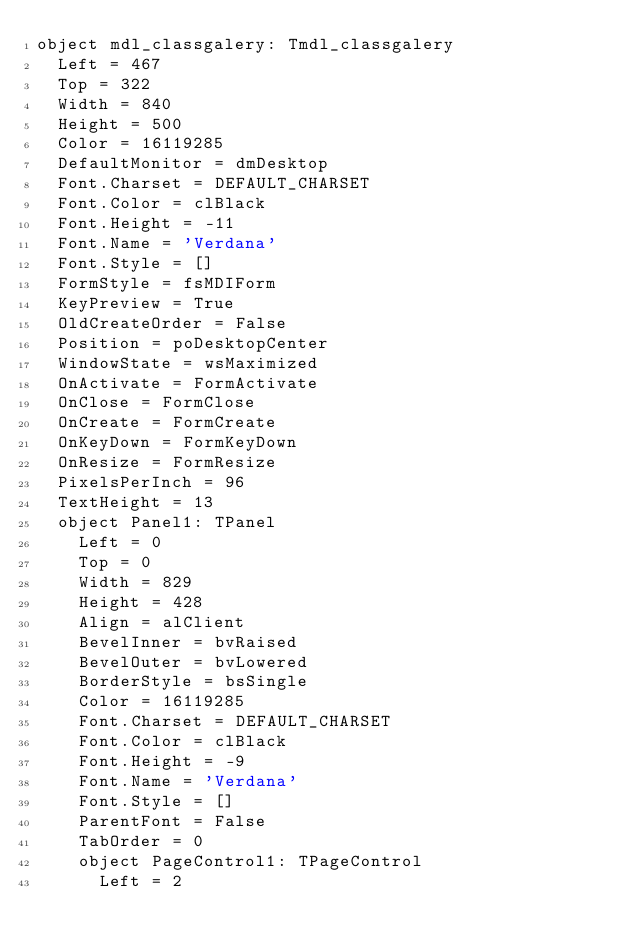<code> <loc_0><loc_0><loc_500><loc_500><_Pascal_>object mdl_classgalery: Tmdl_classgalery
  Left = 467
  Top = 322
  Width = 840
  Height = 500
  Color = 16119285
  DefaultMonitor = dmDesktop
  Font.Charset = DEFAULT_CHARSET
  Font.Color = clBlack
  Font.Height = -11
  Font.Name = 'Verdana'
  Font.Style = []
  FormStyle = fsMDIForm
  KeyPreview = True
  OldCreateOrder = False
  Position = poDesktopCenter
  WindowState = wsMaximized
  OnActivate = FormActivate
  OnClose = FormClose
  OnCreate = FormCreate
  OnKeyDown = FormKeyDown
  OnResize = FormResize
  PixelsPerInch = 96
  TextHeight = 13
  object Panel1: TPanel
    Left = 0
    Top = 0
    Width = 829
    Height = 428
    Align = alClient
    BevelInner = bvRaised
    BevelOuter = bvLowered
    BorderStyle = bsSingle
    Color = 16119285
    Font.Charset = DEFAULT_CHARSET
    Font.Color = clBlack
    Font.Height = -9
    Font.Name = 'Verdana'
    Font.Style = []
    ParentFont = False
    TabOrder = 0
    object PageControl1: TPageControl
      Left = 2</code> 